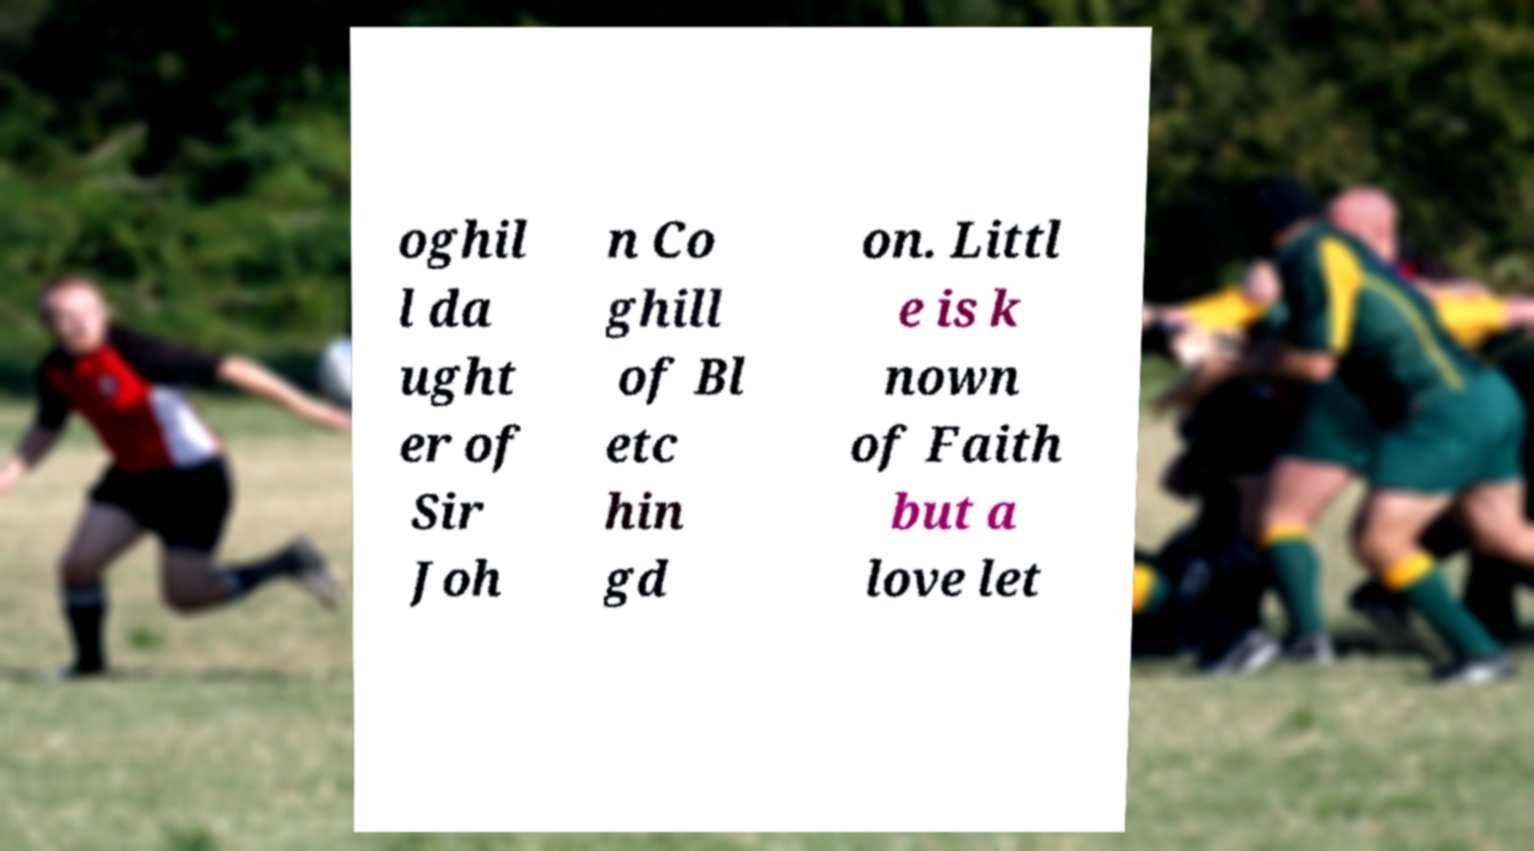Can you read and provide the text displayed in the image?This photo seems to have some interesting text. Can you extract and type it out for me? oghil l da ught er of Sir Joh n Co ghill of Bl etc hin gd on. Littl e is k nown of Faith but a love let 